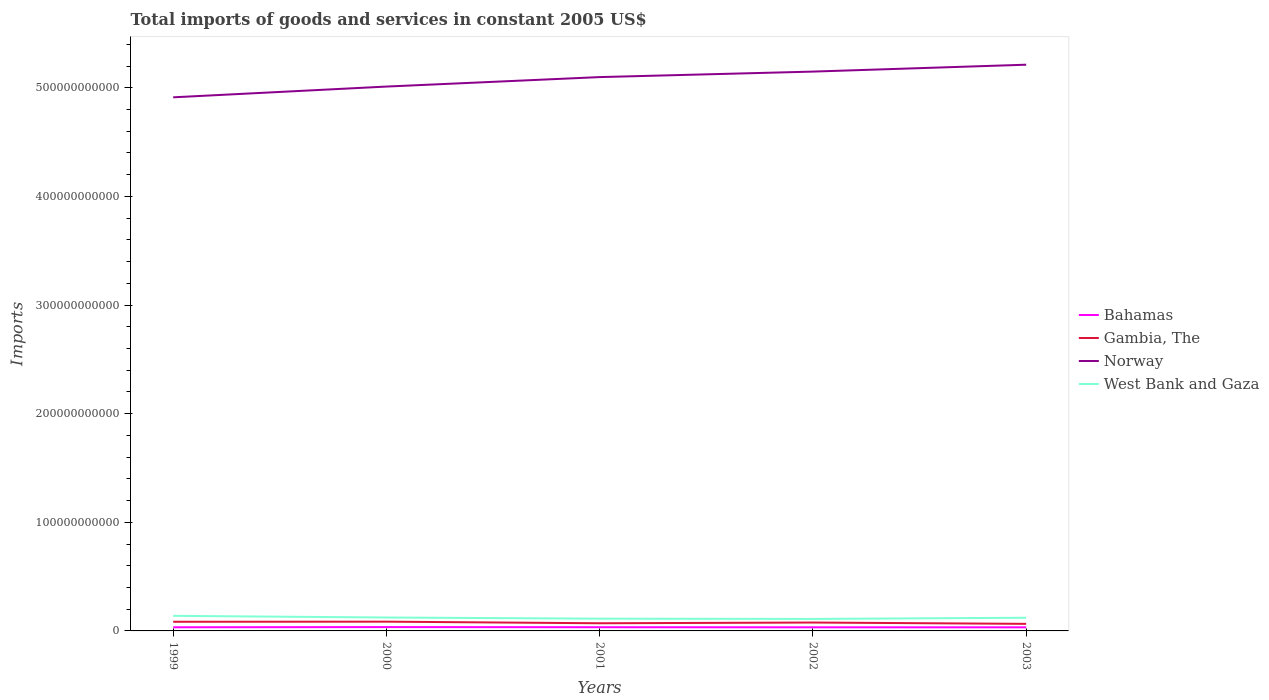Is the number of lines equal to the number of legend labels?
Ensure brevity in your answer.  Yes. Across all years, what is the maximum total imports of goods and services in West Bank and Gaza?
Keep it short and to the point. 1.10e+1. What is the total total imports of goods and services in West Bank and Gaza in the graph?
Keep it short and to the point. 2.28e+08. What is the difference between the highest and the second highest total imports of goods and services in Bahamas?
Provide a short and direct response. 2.28e+08. What is the difference between the highest and the lowest total imports of goods and services in Norway?
Your response must be concise. 3. How many years are there in the graph?
Offer a terse response. 5. What is the difference between two consecutive major ticks on the Y-axis?
Provide a succinct answer. 1.00e+11. Are the values on the major ticks of Y-axis written in scientific E-notation?
Give a very brief answer. No. Does the graph contain grids?
Offer a very short reply. No. How are the legend labels stacked?
Make the answer very short. Vertical. What is the title of the graph?
Provide a short and direct response. Total imports of goods and services in constant 2005 US$. What is the label or title of the X-axis?
Provide a short and direct response. Years. What is the label or title of the Y-axis?
Ensure brevity in your answer.  Imports. What is the Imports of Bahamas in 1999?
Your response must be concise. 3.36e+09. What is the Imports of Gambia, The in 1999?
Make the answer very short. 8.42e+09. What is the Imports in Norway in 1999?
Offer a very short reply. 4.91e+11. What is the Imports of West Bank and Gaza in 1999?
Provide a short and direct response. 1.39e+1. What is the Imports in Bahamas in 2000?
Provide a succinct answer. 3.54e+09. What is the Imports in Gambia, The in 2000?
Ensure brevity in your answer.  8.52e+09. What is the Imports in Norway in 2000?
Provide a succinct answer. 5.01e+11. What is the Imports in West Bank and Gaza in 2000?
Provide a short and direct response. 1.24e+1. What is the Imports of Bahamas in 2001?
Your response must be concise. 3.41e+09. What is the Imports in Gambia, The in 2001?
Provide a short and direct response. 7.05e+09. What is the Imports of Norway in 2001?
Offer a very short reply. 5.10e+11. What is the Imports of West Bank and Gaza in 2001?
Provide a succinct answer. 1.13e+1. What is the Imports of Bahamas in 2002?
Provide a succinct answer. 3.32e+09. What is the Imports of Gambia, The in 2002?
Give a very brief answer. 7.72e+09. What is the Imports of Norway in 2002?
Your answer should be very brief. 5.15e+11. What is the Imports of West Bank and Gaza in 2002?
Your answer should be very brief. 1.10e+1. What is the Imports of Bahamas in 2003?
Your answer should be compact. 3.33e+09. What is the Imports in Gambia, The in 2003?
Keep it short and to the point. 6.50e+09. What is the Imports of Norway in 2003?
Provide a succinct answer. 5.21e+11. What is the Imports in West Bank and Gaza in 2003?
Your response must be concise. 1.21e+1. Across all years, what is the maximum Imports of Bahamas?
Provide a succinct answer. 3.54e+09. Across all years, what is the maximum Imports in Gambia, The?
Provide a succinct answer. 8.52e+09. Across all years, what is the maximum Imports of Norway?
Provide a short and direct response. 5.21e+11. Across all years, what is the maximum Imports of West Bank and Gaza?
Your answer should be compact. 1.39e+1. Across all years, what is the minimum Imports in Bahamas?
Keep it short and to the point. 3.32e+09. Across all years, what is the minimum Imports of Gambia, The?
Give a very brief answer. 6.50e+09. Across all years, what is the minimum Imports in Norway?
Your answer should be compact. 4.91e+11. Across all years, what is the minimum Imports of West Bank and Gaza?
Offer a terse response. 1.10e+1. What is the total Imports of Bahamas in the graph?
Provide a succinct answer. 1.70e+1. What is the total Imports in Gambia, The in the graph?
Your answer should be very brief. 3.82e+1. What is the total Imports in Norway in the graph?
Ensure brevity in your answer.  2.54e+12. What is the total Imports in West Bank and Gaza in the graph?
Your answer should be very brief. 6.07e+1. What is the difference between the Imports in Bahamas in 1999 and that in 2000?
Ensure brevity in your answer.  -1.84e+08. What is the difference between the Imports of Gambia, The in 1999 and that in 2000?
Offer a terse response. -1.01e+08. What is the difference between the Imports of Norway in 1999 and that in 2000?
Give a very brief answer. -9.90e+09. What is the difference between the Imports of West Bank and Gaza in 1999 and that in 2000?
Make the answer very short. 1.52e+09. What is the difference between the Imports in Bahamas in 1999 and that in 2001?
Your answer should be very brief. -5.04e+07. What is the difference between the Imports of Gambia, The in 1999 and that in 2001?
Your answer should be very brief. 1.37e+09. What is the difference between the Imports of Norway in 1999 and that in 2001?
Provide a short and direct response. -1.86e+1. What is the difference between the Imports in West Bank and Gaza in 1999 and that in 2001?
Keep it short and to the point. 2.59e+09. What is the difference between the Imports of Bahamas in 1999 and that in 2002?
Ensure brevity in your answer.  4.41e+07. What is the difference between the Imports in Gambia, The in 1999 and that in 2002?
Provide a short and direct response. 7.04e+08. What is the difference between the Imports of Norway in 1999 and that in 2002?
Keep it short and to the point. -2.37e+1. What is the difference between the Imports in West Bank and Gaza in 1999 and that in 2002?
Provide a succinct answer. 2.84e+09. What is the difference between the Imports of Bahamas in 1999 and that in 2003?
Offer a very short reply. 3.28e+07. What is the difference between the Imports of Gambia, The in 1999 and that in 2003?
Make the answer very short. 1.92e+09. What is the difference between the Imports of Norway in 1999 and that in 2003?
Give a very brief answer. -3.00e+1. What is the difference between the Imports in West Bank and Gaza in 1999 and that in 2003?
Offer a very short reply. 1.75e+09. What is the difference between the Imports of Bahamas in 2000 and that in 2001?
Offer a terse response. 1.34e+08. What is the difference between the Imports of Gambia, The in 2000 and that in 2001?
Make the answer very short. 1.47e+09. What is the difference between the Imports of Norway in 2000 and that in 2001?
Ensure brevity in your answer.  -8.71e+09. What is the difference between the Imports of West Bank and Gaza in 2000 and that in 2001?
Provide a short and direct response. 1.08e+09. What is the difference between the Imports of Bahamas in 2000 and that in 2002?
Your answer should be very brief. 2.28e+08. What is the difference between the Imports of Gambia, The in 2000 and that in 2002?
Keep it short and to the point. 8.05e+08. What is the difference between the Imports in Norway in 2000 and that in 2002?
Offer a very short reply. -1.38e+1. What is the difference between the Imports of West Bank and Gaza in 2000 and that in 2002?
Your answer should be very brief. 1.32e+09. What is the difference between the Imports in Bahamas in 2000 and that in 2003?
Provide a succinct answer. 2.17e+08. What is the difference between the Imports of Gambia, The in 2000 and that in 2003?
Offer a very short reply. 2.02e+09. What is the difference between the Imports of Norway in 2000 and that in 2003?
Offer a terse response. -2.01e+1. What is the difference between the Imports in West Bank and Gaza in 2000 and that in 2003?
Provide a short and direct response. 2.28e+08. What is the difference between the Imports of Bahamas in 2001 and that in 2002?
Keep it short and to the point. 9.45e+07. What is the difference between the Imports of Gambia, The in 2001 and that in 2002?
Provide a short and direct response. -6.70e+08. What is the difference between the Imports of Norway in 2001 and that in 2002?
Provide a short and direct response. -5.07e+09. What is the difference between the Imports in West Bank and Gaza in 2001 and that in 2002?
Make the answer very short. 2.41e+08. What is the difference between the Imports of Bahamas in 2001 and that in 2003?
Your response must be concise. 8.32e+07. What is the difference between the Imports of Gambia, The in 2001 and that in 2003?
Ensure brevity in your answer.  5.50e+08. What is the difference between the Imports in Norway in 2001 and that in 2003?
Provide a short and direct response. -1.14e+1. What is the difference between the Imports of West Bank and Gaza in 2001 and that in 2003?
Offer a terse response. -8.50e+08. What is the difference between the Imports in Bahamas in 2002 and that in 2003?
Give a very brief answer. -1.13e+07. What is the difference between the Imports in Gambia, The in 2002 and that in 2003?
Make the answer very short. 1.22e+09. What is the difference between the Imports of Norway in 2002 and that in 2003?
Ensure brevity in your answer.  -6.34e+09. What is the difference between the Imports of West Bank and Gaza in 2002 and that in 2003?
Ensure brevity in your answer.  -1.09e+09. What is the difference between the Imports in Bahamas in 1999 and the Imports in Gambia, The in 2000?
Your answer should be compact. -5.16e+09. What is the difference between the Imports of Bahamas in 1999 and the Imports of Norway in 2000?
Provide a succinct answer. -4.98e+11. What is the difference between the Imports of Bahamas in 1999 and the Imports of West Bank and Gaza in 2000?
Provide a short and direct response. -9.00e+09. What is the difference between the Imports of Gambia, The in 1999 and the Imports of Norway in 2000?
Your answer should be very brief. -4.93e+11. What is the difference between the Imports of Gambia, The in 1999 and the Imports of West Bank and Gaza in 2000?
Keep it short and to the point. -3.93e+09. What is the difference between the Imports of Norway in 1999 and the Imports of West Bank and Gaza in 2000?
Your answer should be very brief. 4.79e+11. What is the difference between the Imports of Bahamas in 1999 and the Imports of Gambia, The in 2001?
Provide a succinct answer. -3.69e+09. What is the difference between the Imports in Bahamas in 1999 and the Imports in Norway in 2001?
Offer a terse response. -5.06e+11. What is the difference between the Imports in Bahamas in 1999 and the Imports in West Bank and Gaza in 2001?
Provide a succinct answer. -7.92e+09. What is the difference between the Imports in Gambia, The in 1999 and the Imports in Norway in 2001?
Your response must be concise. -5.01e+11. What is the difference between the Imports of Gambia, The in 1999 and the Imports of West Bank and Gaza in 2001?
Give a very brief answer. -2.85e+09. What is the difference between the Imports in Norway in 1999 and the Imports in West Bank and Gaza in 2001?
Provide a short and direct response. 4.80e+11. What is the difference between the Imports in Bahamas in 1999 and the Imports in Gambia, The in 2002?
Offer a terse response. -4.36e+09. What is the difference between the Imports in Bahamas in 1999 and the Imports in Norway in 2002?
Give a very brief answer. -5.12e+11. What is the difference between the Imports in Bahamas in 1999 and the Imports in West Bank and Gaza in 2002?
Keep it short and to the point. -7.68e+09. What is the difference between the Imports in Gambia, The in 1999 and the Imports in Norway in 2002?
Your answer should be very brief. -5.06e+11. What is the difference between the Imports in Gambia, The in 1999 and the Imports in West Bank and Gaza in 2002?
Keep it short and to the point. -2.61e+09. What is the difference between the Imports in Norway in 1999 and the Imports in West Bank and Gaza in 2002?
Ensure brevity in your answer.  4.80e+11. What is the difference between the Imports in Bahamas in 1999 and the Imports in Gambia, The in 2003?
Keep it short and to the point. -3.14e+09. What is the difference between the Imports in Bahamas in 1999 and the Imports in Norway in 2003?
Keep it short and to the point. -5.18e+11. What is the difference between the Imports in Bahamas in 1999 and the Imports in West Bank and Gaza in 2003?
Your answer should be very brief. -8.77e+09. What is the difference between the Imports of Gambia, The in 1999 and the Imports of Norway in 2003?
Your answer should be very brief. -5.13e+11. What is the difference between the Imports of Gambia, The in 1999 and the Imports of West Bank and Gaza in 2003?
Offer a terse response. -3.70e+09. What is the difference between the Imports in Norway in 1999 and the Imports in West Bank and Gaza in 2003?
Provide a succinct answer. 4.79e+11. What is the difference between the Imports of Bahamas in 2000 and the Imports of Gambia, The in 2001?
Ensure brevity in your answer.  -3.51e+09. What is the difference between the Imports in Bahamas in 2000 and the Imports in Norway in 2001?
Your answer should be very brief. -5.06e+11. What is the difference between the Imports of Bahamas in 2000 and the Imports of West Bank and Gaza in 2001?
Make the answer very short. -7.73e+09. What is the difference between the Imports in Gambia, The in 2000 and the Imports in Norway in 2001?
Keep it short and to the point. -5.01e+11. What is the difference between the Imports of Gambia, The in 2000 and the Imports of West Bank and Gaza in 2001?
Offer a terse response. -2.75e+09. What is the difference between the Imports of Norway in 2000 and the Imports of West Bank and Gaza in 2001?
Make the answer very short. 4.90e+11. What is the difference between the Imports of Bahamas in 2000 and the Imports of Gambia, The in 2002?
Make the answer very short. -4.17e+09. What is the difference between the Imports in Bahamas in 2000 and the Imports in Norway in 2002?
Offer a terse response. -5.11e+11. What is the difference between the Imports of Bahamas in 2000 and the Imports of West Bank and Gaza in 2002?
Ensure brevity in your answer.  -7.49e+09. What is the difference between the Imports of Gambia, The in 2000 and the Imports of Norway in 2002?
Your response must be concise. -5.06e+11. What is the difference between the Imports of Gambia, The in 2000 and the Imports of West Bank and Gaza in 2002?
Provide a short and direct response. -2.51e+09. What is the difference between the Imports in Norway in 2000 and the Imports in West Bank and Gaza in 2002?
Ensure brevity in your answer.  4.90e+11. What is the difference between the Imports of Bahamas in 2000 and the Imports of Gambia, The in 2003?
Ensure brevity in your answer.  -2.96e+09. What is the difference between the Imports of Bahamas in 2000 and the Imports of Norway in 2003?
Offer a very short reply. -5.18e+11. What is the difference between the Imports in Bahamas in 2000 and the Imports in West Bank and Gaza in 2003?
Provide a short and direct response. -8.58e+09. What is the difference between the Imports in Gambia, The in 2000 and the Imports in Norway in 2003?
Provide a succinct answer. -5.13e+11. What is the difference between the Imports in Gambia, The in 2000 and the Imports in West Bank and Gaza in 2003?
Ensure brevity in your answer.  -3.60e+09. What is the difference between the Imports in Norway in 2000 and the Imports in West Bank and Gaza in 2003?
Ensure brevity in your answer.  4.89e+11. What is the difference between the Imports in Bahamas in 2001 and the Imports in Gambia, The in 2002?
Provide a succinct answer. -4.31e+09. What is the difference between the Imports of Bahamas in 2001 and the Imports of Norway in 2002?
Make the answer very short. -5.11e+11. What is the difference between the Imports of Bahamas in 2001 and the Imports of West Bank and Gaza in 2002?
Offer a terse response. -7.63e+09. What is the difference between the Imports in Gambia, The in 2001 and the Imports in Norway in 2002?
Ensure brevity in your answer.  -5.08e+11. What is the difference between the Imports of Gambia, The in 2001 and the Imports of West Bank and Gaza in 2002?
Your answer should be compact. -3.99e+09. What is the difference between the Imports of Norway in 2001 and the Imports of West Bank and Gaza in 2002?
Your answer should be compact. 4.99e+11. What is the difference between the Imports in Bahamas in 2001 and the Imports in Gambia, The in 2003?
Give a very brief answer. -3.09e+09. What is the difference between the Imports of Bahamas in 2001 and the Imports of Norway in 2003?
Keep it short and to the point. -5.18e+11. What is the difference between the Imports in Bahamas in 2001 and the Imports in West Bank and Gaza in 2003?
Your response must be concise. -8.72e+09. What is the difference between the Imports in Gambia, The in 2001 and the Imports in Norway in 2003?
Give a very brief answer. -5.14e+11. What is the difference between the Imports in Gambia, The in 2001 and the Imports in West Bank and Gaza in 2003?
Offer a very short reply. -5.08e+09. What is the difference between the Imports in Norway in 2001 and the Imports in West Bank and Gaza in 2003?
Your answer should be compact. 4.98e+11. What is the difference between the Imports in Bahamas in 2002 and the Imports in Gambia, The in 2003?
Keep it short and to the point. -3.18e+09. What is the difference between the Imports in Bahamas in 2002 and the Imports in Norway in 2003?
Offer a very short reply. -5.18e+11. What is the difference between the Imports in Bahamas in 2002 and the Imports in West Bank and Gaza in 2003?
Provide a short and direct response. -8.81e+09. What is the difference between the Imports in Gambia, The in 2002 and the Imports in Norway in 2003?
Provide a succinct answer. -5.13e+11. What is the difference between the Imports of Gambia, The in 2002 and the Imports of West Bank and Gaza in 2003?
Your response must be concise. -4.41e+09. What is the difference between the Imports of Norway in 2002 and the Imports of West Bank and Gaza in 2003?
Provide a short and direct response. 5.03e+11. What is the average Imports in Bahamas per year?
Give a very brief answer. 3.39e+09. What is the average Imports in Gambia, The per year?
Make the answer very short. 7.64e+09. What is the average Imports in Norway per year?
Provide a succinct answer. 5.08e+11. What is the average Imports in West Bank and Gaza per year?
Provide a succinct answer. 1.21e+1. In the year 1999, what is the difference between the Imports of Bahamas and Imports of Gambia, The?
Make the answer very short. -5.06e+09. In the year 1999, what is the difference between the Imports in Bahamas and Imports in Norway?
Your answer should be very brief. -4.88e+11. In the year 1999, what is the difference between the Imports in Bahamas and Imports in West Bank and Gaza?
Offer a terse response. -1.05e+1. In the year 1999, what is the difference between the Imports in Gambia, The and Imports in Norway?
Offer a very short reply. -4.83e+11. In the year 1999, what is the difference between the Imports of Gambia, The and Imports of West Bank and Gaza?
Keep it short and to the point. -5.45e+09. In the year 1999, what is the difference between the Imports of Norway and Imports of West Bank and Gaza?
Provide a short and direct response. 4.77e+11. In the year 2000, what is the difference between the Imports of Bahamas and Imports of Gambia, The?
Make the answer very short. -4.98e+09. In the year 2000, what is the difference between the Imports in Bahamas and Imports in Norway?
Provide a short and direct response. -4.98e+11. In the year 2000, what is the difference between the Imports in Bahamas and Imports in West Bank and Gaza?
Keep it short and to the point. -8.81e+09. In the year 2000, what is the difference between the Imports in Gambia, The and Imports in Norway?
Ensure brevity in your answer.  -4.93e+11. In the year 2000, what is the difference between the Imports of Gambia, The and Imports of West Bank and Gaza?
Your answer should be compact. -3.83e+09. In the year 2000, what is the difference between the Imports of Norway and Imports of West Bank and Gaza?
Provide a succinct answer. 4.89e+11. In the year 2001, what is the difference between the Imports of Bahamas and Imports of Gambia, The?
Provide a short and direct response. -3.64e+09. In the year 2001, what is the difference between the Imports of Bahamas and Imports of Norway?
Your response must be concise. -5.06e+11. In the year 2001, what is the difference between the Imports in Bahamas and Imports in West Bank and Gaza?
Provide a short and direct response. -7.87e+09. In the year 2001, what is the difference between the Imports in Gambia, The and Imports in Norway?
Give a very brief answer. -5.03e+11. In the year 2001, what is the difference between the Imports of Gambia, The and Imports of West Bank and Gaza?
Your response must be concise. -4.23e+09. In the year 2001, what is the difference between the Imports in Norway and Imports in West Bank and Gaza?
Offer a very short reply. 4.99e+11. In the year 2002, what is the difference between the Imports of Bahamas and Imports of Gambia, The?
Keep it short and to the point. -4.40e+09. In the year 2002, what is the difference between the Imports of Bahamas and Imports of Norway?
Give a very brief answer. -5.12e+11. In the year 2002, what is the difference between the Imports of Bahamas and Imports of West Bank and Gaza?
Provide a succinct answer. -7.72e+09. In the year 2002, what is the difference between the Imports in Gambia, The and Imports in Norway?
Give a very brief answer. -5.07e+11. In the year 2002, what is the difference between the Imports in Gambia, The and Imports in West Bank and Gaza?
Provide a short and direct response. -3.32e+09. In the year 2002, what is the difference between the Imports of Norway and Imports of West Bank and Gaza?
Make the answer very short. 5.04e+11. In the year 2003, what is the difference between the Imports in Bahamas and Imports in Gambia, The?
Ensure brevity in your answer.  -3.17e+09. In the year 2003, what is the difference between the Imports of Bahamas and Imports of Norway?
Your answer should be compact. -5.18e+11. In the year 2003, what is the difference between the Imports in Bahamas and Imports in West Bank and Gaza?
Offer a very short reply. -8.80e+09. In the year 2003, what is the difference between the Imports of Gambia, The and Imports of Norway?
Your answer should be compact. -5.15e+11. In the year 2003, what is the difference between the Imports of Gambia, The and Imports of West Bank and Gaza?
Keep it short and to the point. -5.63e+09. In the year 2003, what is the difference between the Imports of Norway and Imports of West Bank and Gaza?
Give a very brief answer. 5.09e+11. What is the ratio of the Imports in Bahamas in 1999 to that in 2000?
Give a very brief answer. 0.95. What is the ratio of the Imports of Norway in 1999 to that in 2000?
Your answer should be compact. 0.98. What is the ratio of the Imports of West Bank and Gaza in 1999 to that in 2000?
Your response must be concise. 1.12. What is the ratio of the Imports of Bahamas in 1999 to that in 2001?
Your answer should be compact. 0.99. What is the ratio of the Imports of Gambia, The in 1999 to that in 2001?
Give a very brief answer. 1.19. What is the ratio of the Imports of Norway in 1999 to that in 2001?
Provide a succinct answer. 0.96. What is the ratio of the Imports in West Bank and Gaza in 1999 to that in 2001?
Your answer should be compact. 1.23. What is the ratio of the Imports in Bahamas in 1999 to that in 2002?
Offer a terse response. 1.01. What is the ratio of the Imports of Gambia, The in 1999 to that in 2002?
Offer a very short reply. 1.09. What is the ratio of the Imports in Norway in 1999 to that in 2002?
Offer a terse response. 0.95. What is the ratio of the Imports of West Bank and Gaza in 1999 to that in 2002?
Make the answer very short. 1.26. What is the ratio of the Imports of Bahamas in 1999 to that in 2003?
Offer a terse response. 1.01. What is the ratio of the Imports of Gambia, The in 1999 to that in 2003?
Keep it short and to the point. 1.3. What is the ratio of the Imports in Norway in 1999 to that in 2003?
Provide a short and direct response. 0.94. What is the ratio of the Imports of West Bank and Gaza in 1999 to that in 2003?
Your answer should be very brief. 1.14. What is the ratio of the Imports of Bahamas in 2000 to that in 2001?
Your response must be concise. 1.04. What is the ratio of the Imports in Gambia, The in 2000 to that in 2001?
Keep it short and to the point. 1.21. What is the ratio of the Imports in Norway in 2000 to that in 2001?
Give a very brief answer. 0.98. What is the ratio of the Imports in West Bank and Gaza in 2000 to that in 2001?
Offer a very short reply. 1.1. What is the ratio of the Imports of Bahamas in 2000 to that in 2002?
Offer a terse response. 1.07. What is the ratio of the Imports in Gambia, The in 2000 to that in 2002?
Make the answer very short. 1.1. What is the ratio of the Imports of Norway in 2000 to that in 2002?
Your response must be concise. 0.97. What is the ratio of the Imports in West Bank and Gaza in 2000 to that in 2002?
Give a very brief answer. 1.12. What is the ratio of the Imports of Bahamas in 2000 to that in 2003?
Provide a succinct answer. 1.07. What is the ratio of the Imports of Gambia, The in 2000 to that in 2003?
Give a very brief answer. 1.31. What is the ratio of the Imports in Norway in 2000 to that in 2003?
Make the answer very short. 0.96. What is the ratio of the Imports of West Bank and Gaza in 2000 to that in 2003?
Your response must be concise. 1.02. What is the ratio of the Imports in Bahamas in 2001 to that in 2002?
Your answer should be compact. 1.03. What is the ratio of the Imports in Gambia, The in 2001 to that in 2002?
Your answer should be compact. 0.91. What is the ratio of the Imports in Norway in 2001 to that in 2002?
Offer a very short reply. 0.99. What is the ratio of the Imports of West Bank and Gaza in 2001 to that in 2002?
Make the answer very short. 1.02. What is the ratio of the Imports of Bahamas in 2001 to that in 2003?
Ensure brevity in your answer.  1.02. What is the ratio of the Imports of Gambia, The in 2001 to that in 2003?
Give a very brief answer. 1.08. What is the ratio of the Imports of Norway in 2001 to that in 2003?
Offer a very short reply. 0.98. What is the ratio of the Imports in West Bank and Gaza in 2001 to that in 2003?
Ensure brevity in your answer.  0.93. What is the ratio of the Imports of Bahamas in 2002 to that in 2003?
Make the answer very short. 1. What is the ratio of the Imports of Gambia, The in 2002 to that in 2003?
Offer a terse response. 1.19. What is the ratio of the Imports of Norway in 2002 to that in 2003?
Provide a succinct answer. 0.99. What is the ratio of the Imports of West Bank and Gaza in 2002 to that in 2003?
Give a very brief answer. 0.91. What is the difference between the highest and the second highest Imports in Bahamas?
Ensure brevity in your answer.  1.34e+08. What is the difference between the highest and the second highest Imports in Gambia, The?
Provide a short and direct response. 1.01e+08. What is the difference between the highest and the second highest Imports in Norway?
Provide a succinct answer. 6.34e+09. What is the difference between the highest and the second highest Imports in West Bank and Gaza?
Your answer should be very brief. 1.52e+09. What is the difference between the highest and the lowest Imports in Bahamas?
Your response must be concise. 2.28e+08. What is the difference between the highest and the lowest Imports in Gambia, The?
Offer a terse response. 2.02e+09. What is the difference between the highest and the lowest Imports of Norway?
Provide a short and direct response. 3.00e+1. What is the difference between the highest and the lowest Imports in West Bank and Gaza?
Offer a very short reply. 2.84e+09. 